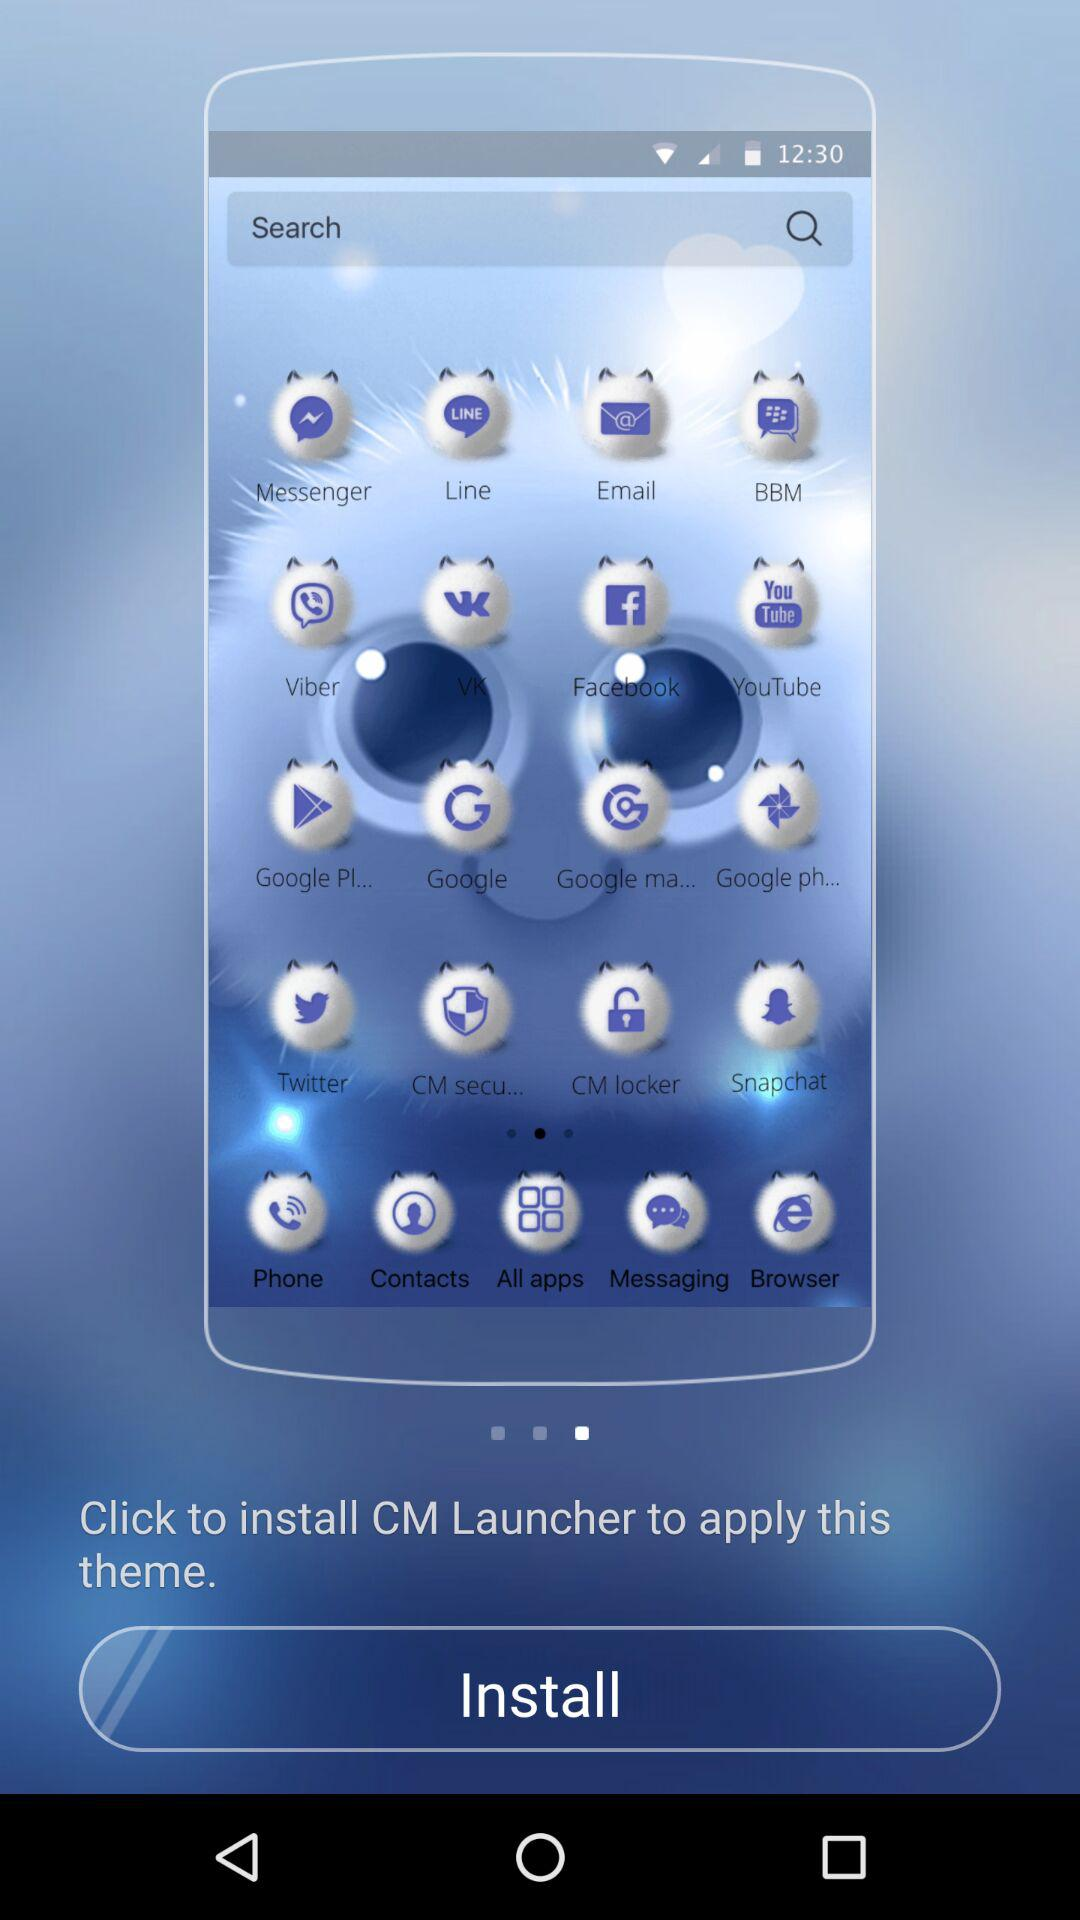How many themes are available with "CM Launcher"?
When the provided information is insufficient, respond with <no answer>. <no answer> 